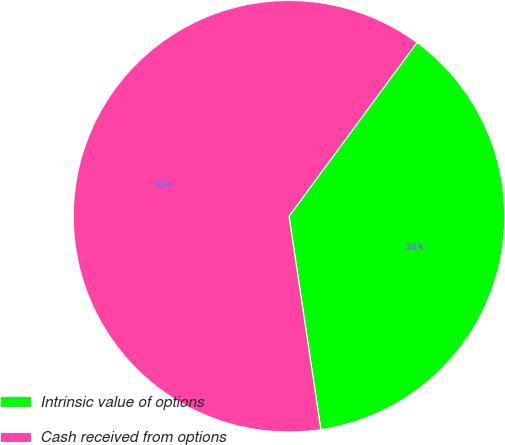Convert chart. <chart><loc_0><loc_0><loc_500><loc_500><pie_chart><fcel>Intrinsic value of options<fcel>Cash received from options<nl><fcel>37.54%<fcel>62.46%<nl></chart> 